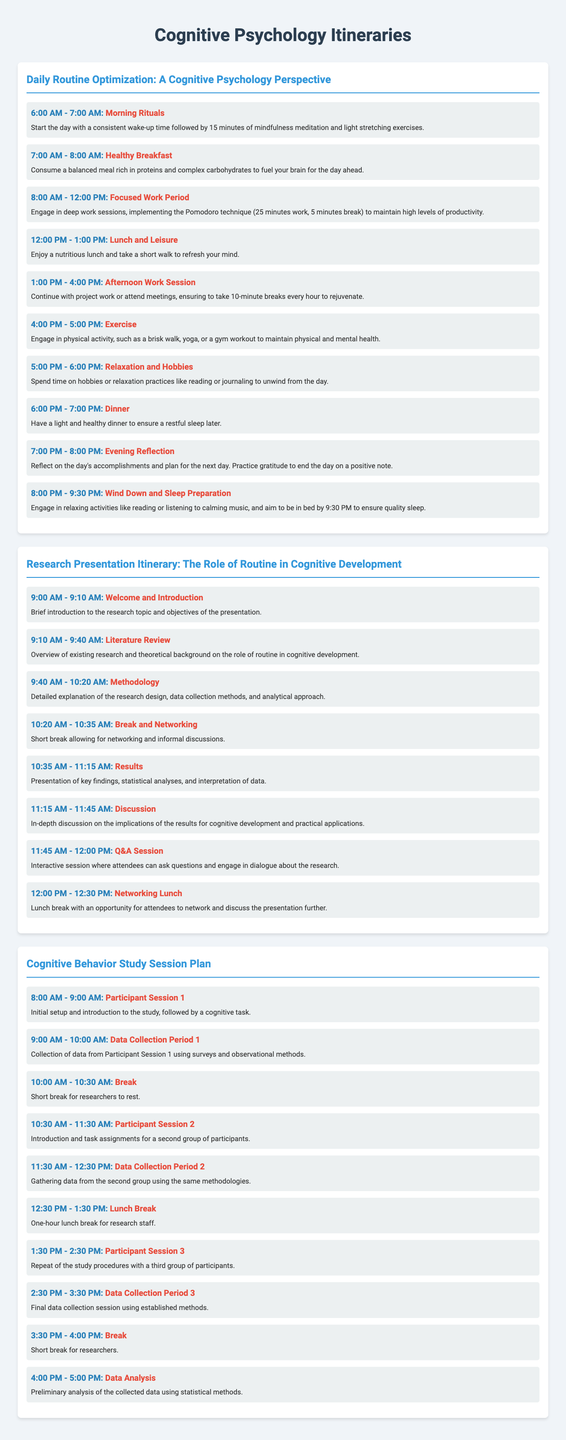What is the start time for the morning rituals? The itinerary states that morning rituals start at 6:00 AM.
Answer: 6:00 AM How long is the lunch break in the research presentation itinerary? The lunch break is scheduled for 30 minutes after the Q&A session.
Answer: 30 minutes What activity is scheduled at 4:00 PM in the Daily Routine Optimization itinerary? The plan includes engaging in exercise at 4:00 PM.
Answer: Exercise How many participant sessions are planned in the Cognitive Behavior Study Session Plan? There are three participant sessions outlined in the schedule.
Answer: Three What is the title of the first itinerary in the document? The first itinerary is titled "Daily Routine Optimization: A Cognitive Psychology Perspective."
Answer: Daily Routine Optimization: A Cognitive Psychology Perspective During which time frame does the results presentation occur in the research presentation? The results are presented from 10:35 AM to 11:15 AM.
Answer: 10:35 AM - 11:15 AM What is the final activity listed for the Daily Routine Optimization itinerary? The last listed activity is wind down and sleep preparation at 8:00 PM.
Answer: Wind Down and Sleep Preparation What session follows the break in the research presentation itinerary? The session after the break is the results presentation.
Answer: Results What is the purpose of the evening reflection in the Daily Routine Optimization? The evening reflection aims to reflect on the day's accomplishments and practice gratitude.
Answer: Reflect on the day's accomplishments and practice gratitude 